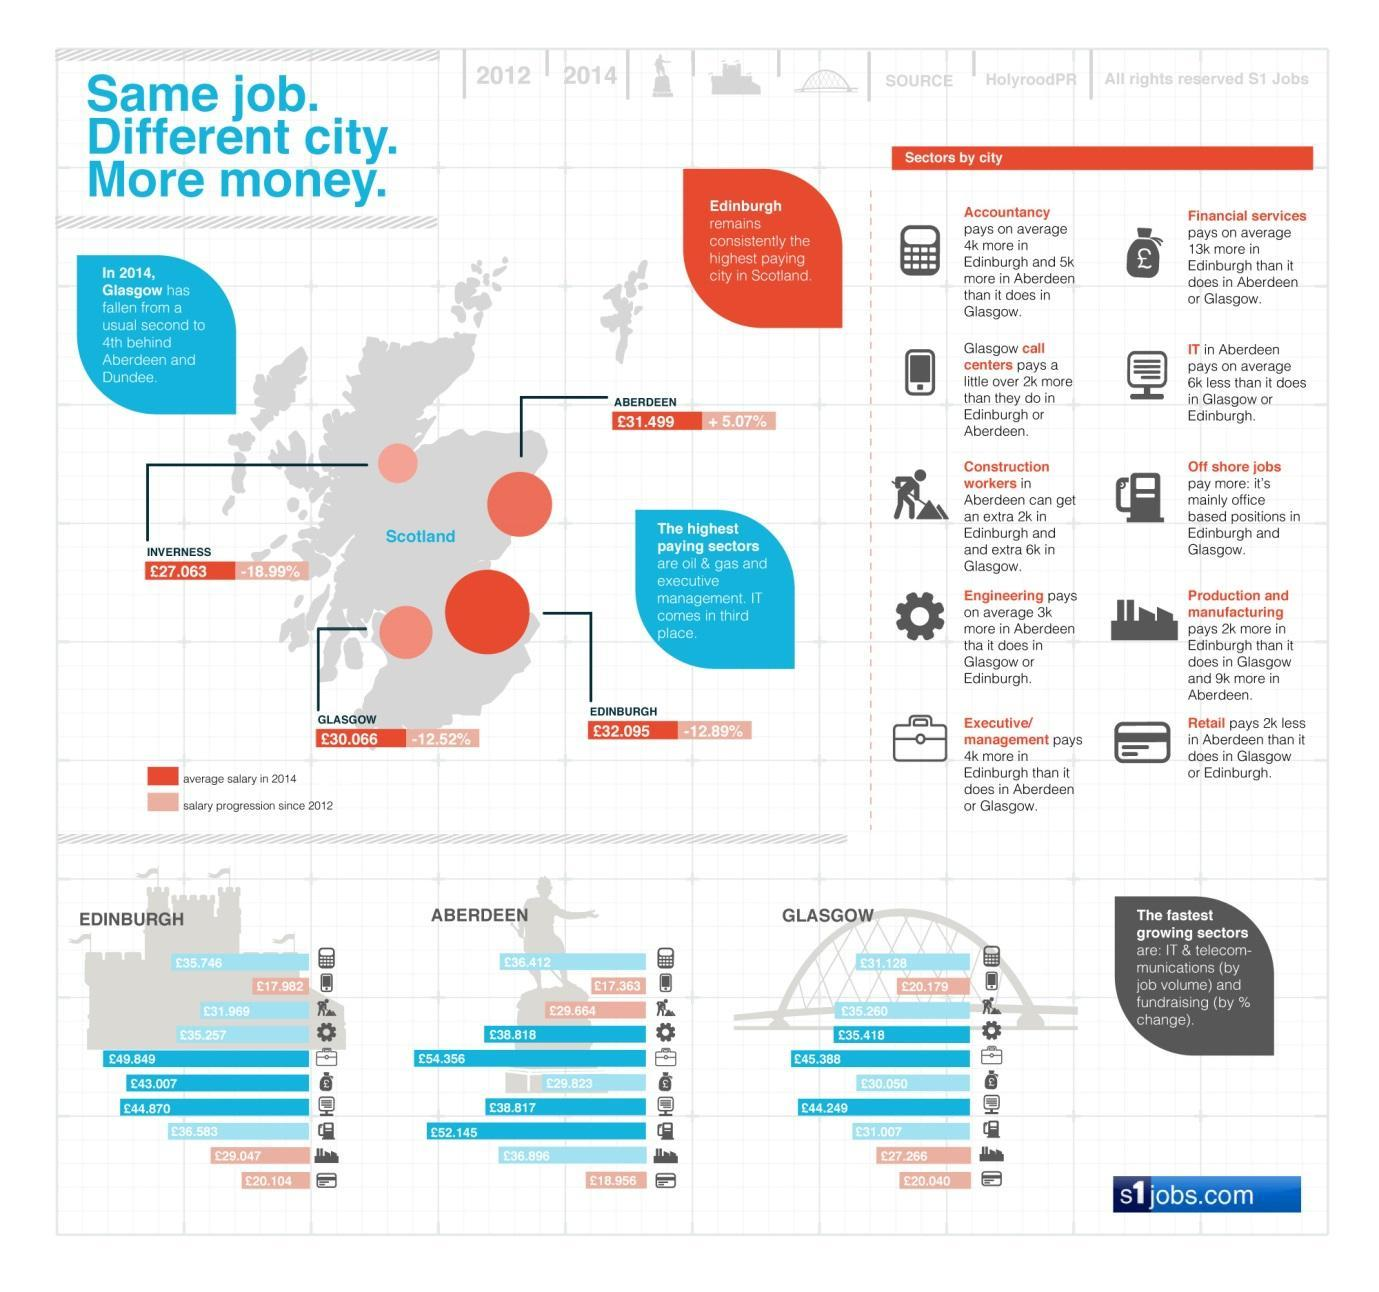What is the salary progression in the Aberdeen city of Scotland since 2012?
Answer the question with a short phrase. +5.07% What is the average salary paid for construction workers in the Glasglow city in 2014? £35,260 What is the average salary paid for Engineering jobs in the Aberdeen city in 2014? £38.818 What is the salary progression in the Edinburgh city of Scotland since 2012? -12.89% What is the average salary in accountancy sector in the Edinburgh city in 2014? £35.746 What is the salary progression in the Glasgow city of Scotland since 2012? -12.52% Which is the least paying sector in the Edinburgh city in 2014? call centers What is the average salary in Glasgow  city of Scotland in 2014? £30.066 What is the average salary in Edinburgh city of Scotland in 2014? £32.015 